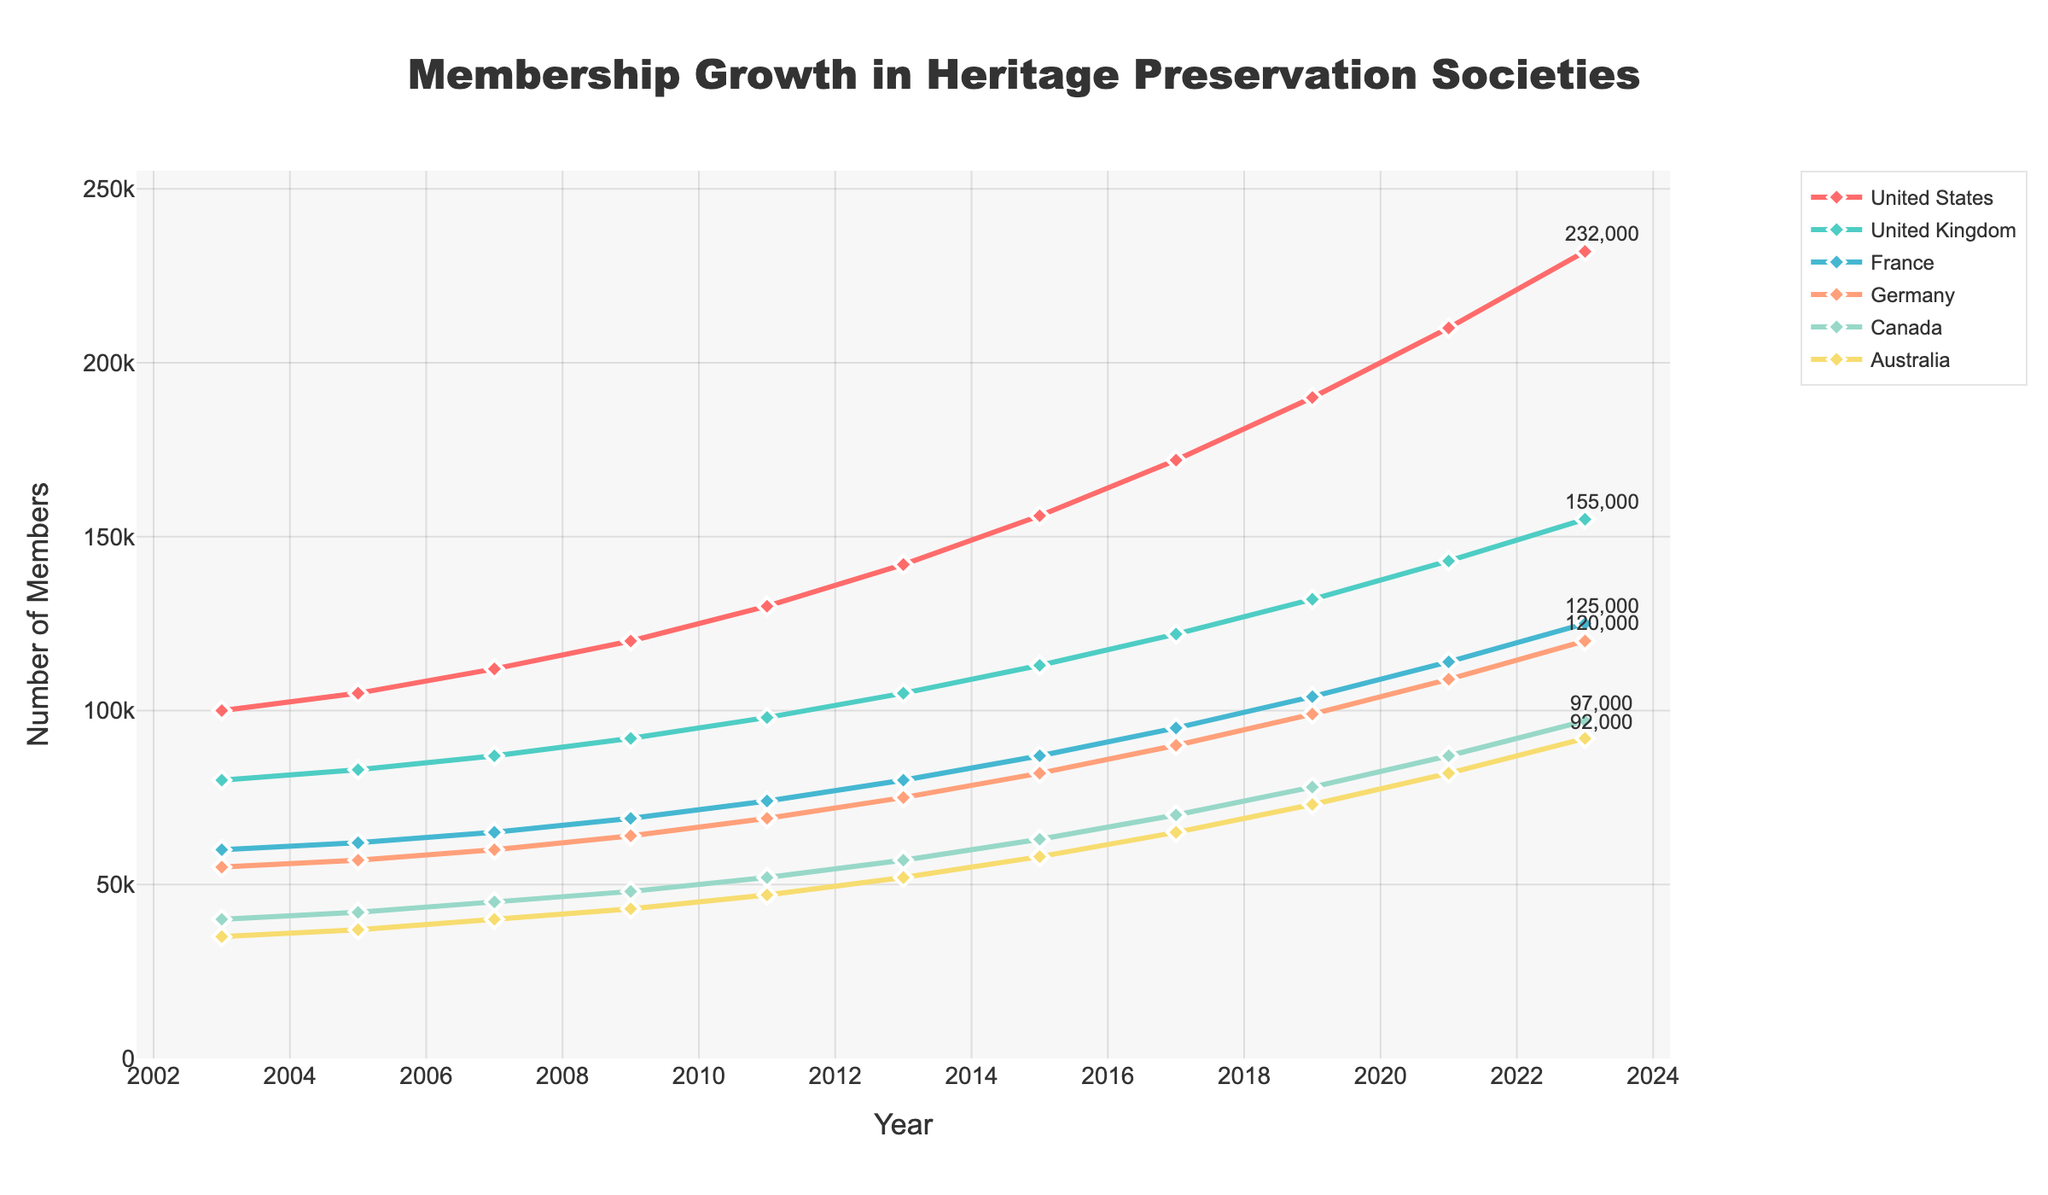What is the overall trend in membership for the United States over the 20 years? The line chart shows a steady and significant increase in the number of members in the United States from 100,000 members in 2003 to 232,000 members in 2023.
Answer: Increasing In which year did Germany's membership first exceed 100,000? Looking at the line for Germany, the membership reached 100,000 after the year 2019, and by 2021 it was at 109,000 members.
Answer: 2021 Which country had the highest growth in membership from 2003 to 2023? Comparing the endpoints of each country's line, the United States had the highest growth from 100,000 in 2003 to 232,000 in 2023, an increase of 132,000 members.
Answer: United States By how much did Canada's membership increase between 2011 and 2023? From the figure, Canada's membership in 2011 was 52,000 and in 2023 was 97,000. The increase is 97,000 - 52,000 = 45,000 members.
Answer: 45,000 Compare the growth rate of heritage society memberships between France and Australia from 2003 to 2023. France’s membership grew from 60,000 to 125,000 (an increase of 65,000), while Australia's membership grew from 35,000 to 92,000 (an increase of 57,000). Since France has higher absolute growth, it leads in the growth rate as well.
Answer: France has a higher growth rate What was the average membership of the United Kingdom between 2003 and 2023? The memberships for the United Kingdom over the years are 80,000, 83,000, 87,000, 92,000, 98,000, 105,000, 113,000, 122,000, 132,000, 143,000, and 155,000 respectively. Adding these values and dividing by 11 (the number of years) gives the average: (80,000 + 83,000 + 87,000 + 92,000 + 98,000 + 105,000 + 113,000 + 122,000 + 132,000 + 143,000 + 155,000) / 11 ≈ 108,000 members.
Answer: 108,000 Which country had the least membership growth over the 20 years, and what was the increase? By examining the growth of all countries, Australia had the least growth. Its membership increased from 35,000 in 2003 to 92,000 in 2023, a total increase of 57,000 members.
Answer: Australia, 57,000 How does the membership growth in Canada compare visually to France on the chart? Visually, both countries show an upward trend. However, Canada's line remains below France consistently throughout the period, highlighted by their final values of 97,000 (Canada) and 125,000 (France).
Answer: Canada's growth is less than France's What is the difference in membership between the United States and the United Kingdom in 2023? In 2023, the membership in the United States is 232,000, and in the United Kingdom, it is 155,000. The difference is 232,000 - 155,000 = 77,000 members.
Answer: 77,000 Which countries had a membership of over 100,000 in 2019? From the figure, the countries with memberships exceeding 100,000 in 2019 are the United States (190,000) and the United Kingdom (132,000). France and Germany were close but both were below 100,000.
Answer: United States, United Kingdom 